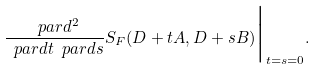Convert formula to latex. <formula><loc_0><loc_0><loc_500><loc_500>\frac { \ p a r d ^ { 2 } } { \ p a r d t \ p a r d s } S _ { F } ( D + t A , D + s B ) \Big | _ { t = s = 0 } .</formula> 